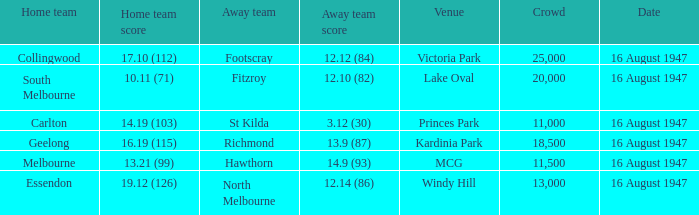What was the total size of the crowd when the away team scored 12.10 (82)? 20000.0. 